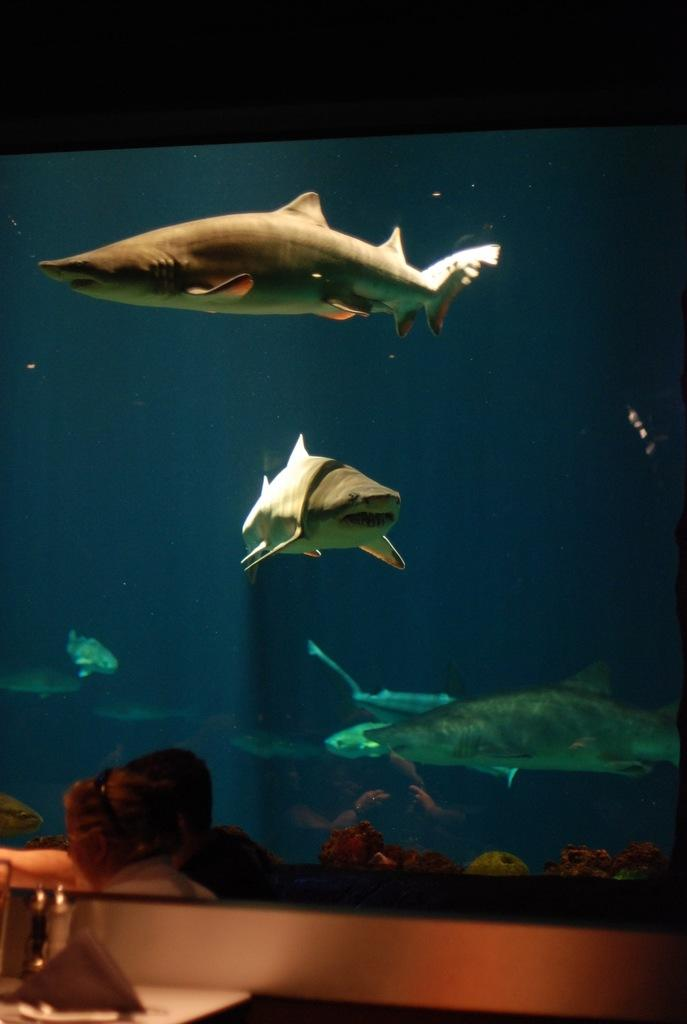What is present in the water in the image? There are fishes in the water in the image. What piece of furniture can be seen in the image? There is a table in the image. What object is on the table for holding tissue papers? There is a tissue paper stand on the table. What else can be found on the table in the image? There are bottles on the table. What type of nerve can be seen in the image? There is no nerve present in the image. Is there a corn field visible in the image? There is no corn field or corn present in the image. 